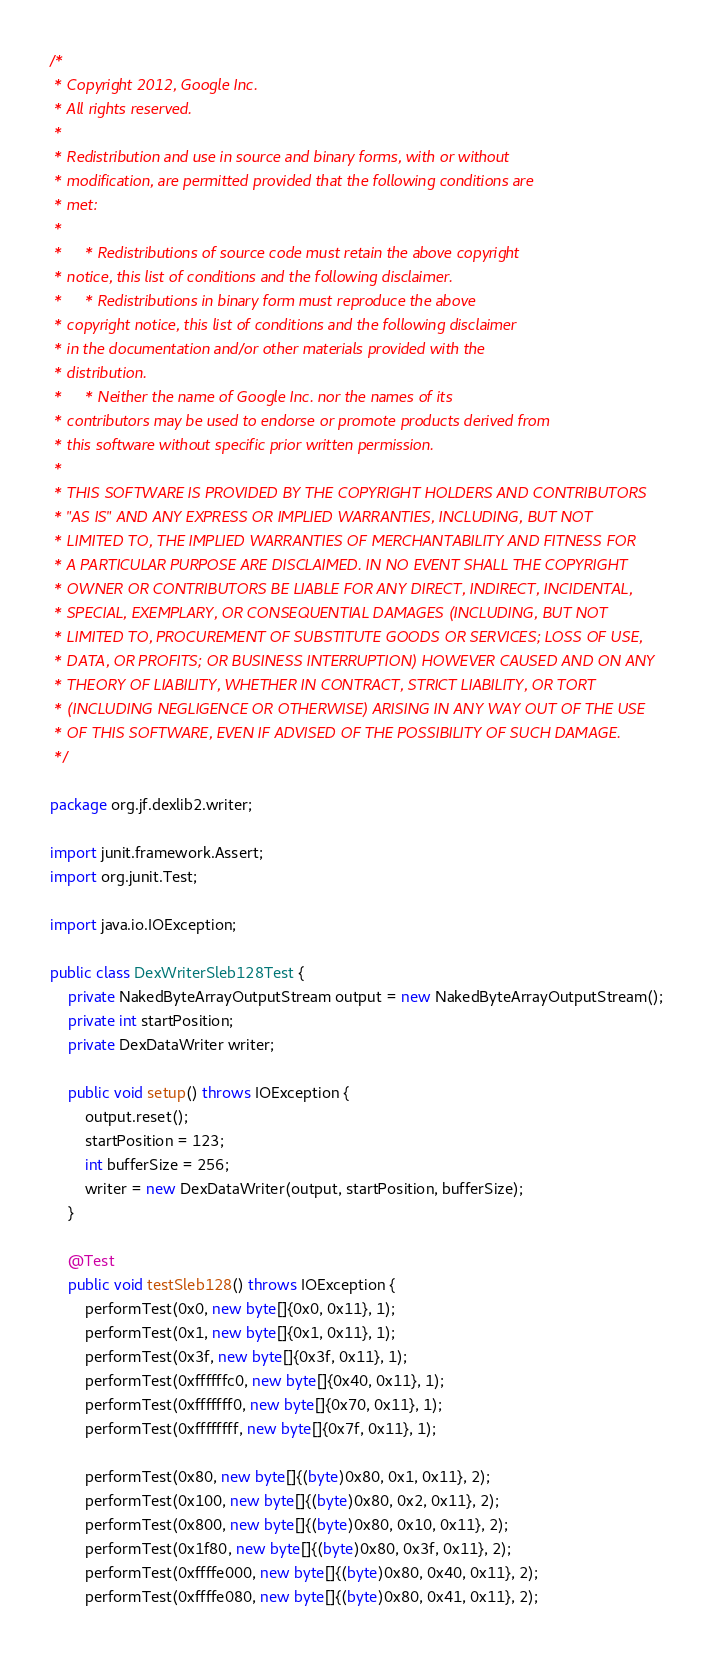Convert code to text. <code><loc_0><loc_0><loc_500><loc_500><_Java_>/*
 * Copyright 2012, Google Inc.
 * All rights reserved.
 *
 * Redistribution and use in source and binary forms, with or without
 * modification, are permitted provided that the following conditions are
 * met:
 *
 *     * Redistributions of source code must retain the above copyright
 * notice, this list of conditions and the following disclaimer.
 *     * Redistributions in binary form must reproduce the above
 * copyright notice, this list of conditions and the following disclaimer
 * in the documentation and/or other materials provided with the
 * distribution.
 *     * Neither the name of Google Inc. nor the names of its
 * contributors may be used to endorse or promote products derived from
 * this software without specific prior written permission.
 *
 * THIS SOFTWARE IS PROVIDED BY THE COPYRIGHT HOLDERS AND CONTRIBUTORS
 * "AS IS" AND ANY EXPRESS OR IMPLIED WARRANTIES, INCLUDING, BUT NOT
 * LIMITED TO, THE IMPLIED WARRANTIES OF MERCHANTABILITY AND FITNESS FOR
 * A PARTICULAR PURPOSE ARE DISCLAIMED. IN NO EVENT SHALL THE COPYRIGHT
 * OWNER OR CONTRIBUTORS BE LIABLE FOR ANY DIRECT, INDIRECT, INCIDENTAL,
 * SPECIAL, EXEMPLARY, OR CONSEQUENTIAL DAMAGES (INCLUDING, BUT NOT
 * LIMITED TO, PROCUREMENT OF SUBSTITUTE GOODS OR SERVICES; LOSS OF USE,
 * DATA, OR PROFITS; OR BUSINESS INTERRUPTION) HOWEVER CAUSED AND ON ANY
 * THEORY OF LIABILITY, WHETHER IN CONTRACT, STRICT LIABILITY, OR TORT
 * (INCLUDING NEGLIGENCE OR OTHERWISE) ARISING IN ANY WAY OUT OF THE USE
 * OF THIS SOFTWARE, EVEN IF ADVISED OF THE POSSIBILITY OF SUCH DAMAGE.
 */

package org.jf.dexlib2.writer;

import junit.framework.Assert;
import org.junit.Test;

import java.io.IOException;

public class DexWriterSleb128Test {
    private NakedByteArrayOutputStream output = new NakedByteArrayOutputStream();
    private int startPosition;
    private DexDataWriter writer;

    public void setup() throws IOException {
        output.reset();
        startPosition = 123;
        int bufferSize = 256;
        writer = new DexDataWriter(output, startPosition, bufferSize);
    }

    @Test
    public void testSleb128() throws IOException {
        performTest(0x0, new byte[]{0x0, 0x11}, 1);
        performTest(0x1, new byte[]{0x1, 0x11}, 1);
        performTest(0x3f, new byte[]{0x3f, 0x11}, 1);
        performTest(0xffffffc0, new byte[]{0x40, 0x11}, 1);
        performTest(0xfffffff0, new byte[]{0x70, 0x11}, 1);
        performTest(0xffffffff, new byte[]{0x7f, 0x11}, 1);

        performTest(0x80, new byte[]{(byte)0x80, 0x1, 0x11}, 2);
        performTest(0x100, new byte[]{(byte)0x80, 0x2, 0x11}, 2);
        performTest(0x800, new byte[]{(byte)0x80, 0x10, 0x11}, 2);
        performTest(0x1f80, new byte[]{(byte)0x80, 0x3f, 0x11}, 2);
        performTest(0xffffe000, new byte[]{(byte)0x80, 0x40, 0x11}, 2);
        performTest(0xffffe080, new byte[]{(byte)0x80, 0x41, 0x11}, 2);</code> 